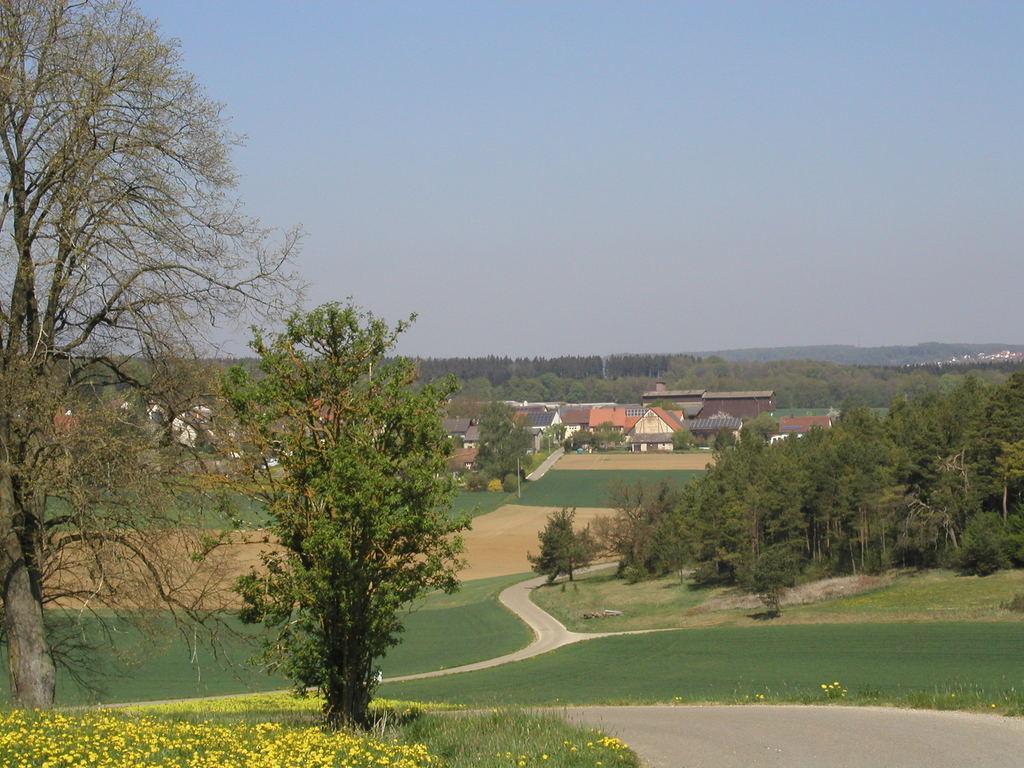Could you give a brief overview of what you see in this image? We can see trees,flowers and grass. In the background we can see houses,trees and sky. 